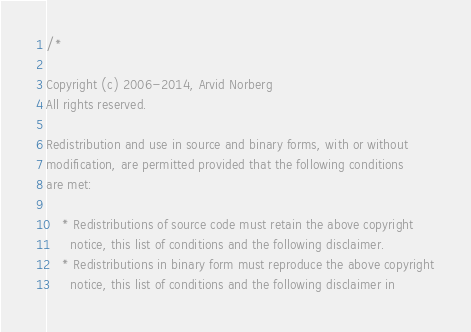Convert code to text. <code><loc_0><loc_0><loc_500><loc_500><_C++_>/*

Copyright (c) 2006-2014, Arvid Norberg
All rights reserved.

Redistribution and use in source and binary forms, with or without
modification, are permitted provided that the following conditions
are met:

    * Redistributions of source code must retain the above copyright
      notice, this list of conditions and the following disclaimer.
    * Redistributions in binary form must reproduce the above copyright
      notice, this list of conditions and the following disclaimer in</code> 